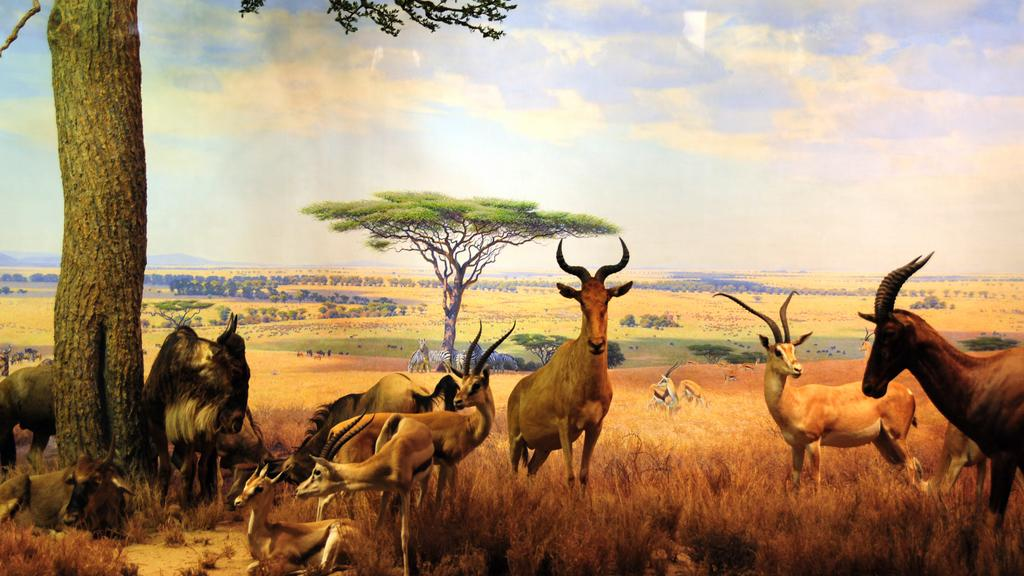What can be observed about the image that suggests it has been edited? The image appears to be edited, as the different types of animals in the image are not typically found together in a natural setting. What types of animals can be seen in the image? There are different types of animals in the image, including those that are not usually found together in a natural setting. What type of vegetation is present in the image? There is dried grass in the image. What can be seen in the sky in the image? There are clouds in the sky in the image. What time is displayed on the clock in the image? There is no clock present in the image. What color are the crayons used to draw the animals in the image? There are no crayons or drawings in the image; it appears to be a photograph of real animals. 